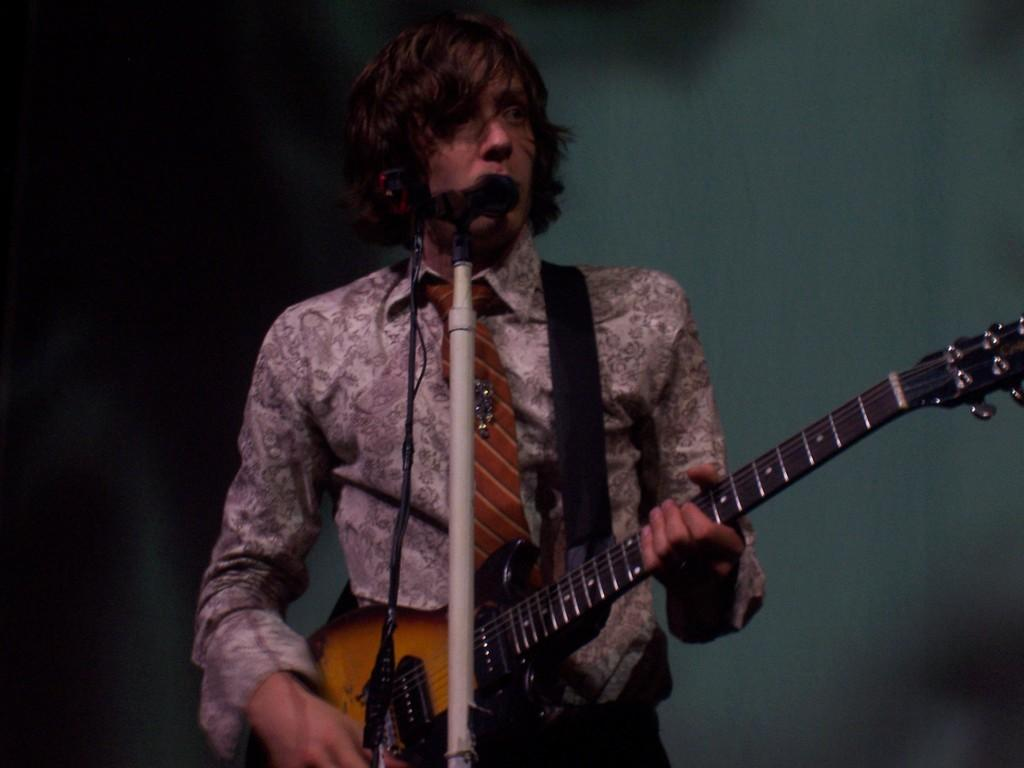What is the main subject of the image? There is a person in the image. What is the person doing in the image? The person is standing in the image. What object is the person holding in the image? The person is holding a guitar in the image. What object is in front of the person in the image? The person is standing in front of a microphone in the image. What type of clothing is the person wearing in the image? The person is wearing a shirt and tie in the image. What type of ring is the person wearing on their finger in the image? There is no ring visible on the person's finger in the image. What type of throne is the person sitting on in the image? There is no throne present in the image; the person is standing. 